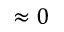Convert formula to latex. <formula><loc_0><loc_0><loc_500><loc_500>\approx 0</formula> 